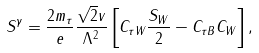<formula> <loc_0><loc_0><loc_500><loc_500>S ^ { \gamma } = \frac { 2 m _ { \tau } } { e } \frac { \sqrt { 2 } v } { \Lambda ^ { 2 } } \left [ C _ { \tau W } \frac { S _ { W } } { 2 } - C _ { \tau B } C _ { W } \right ] ,</formula> 